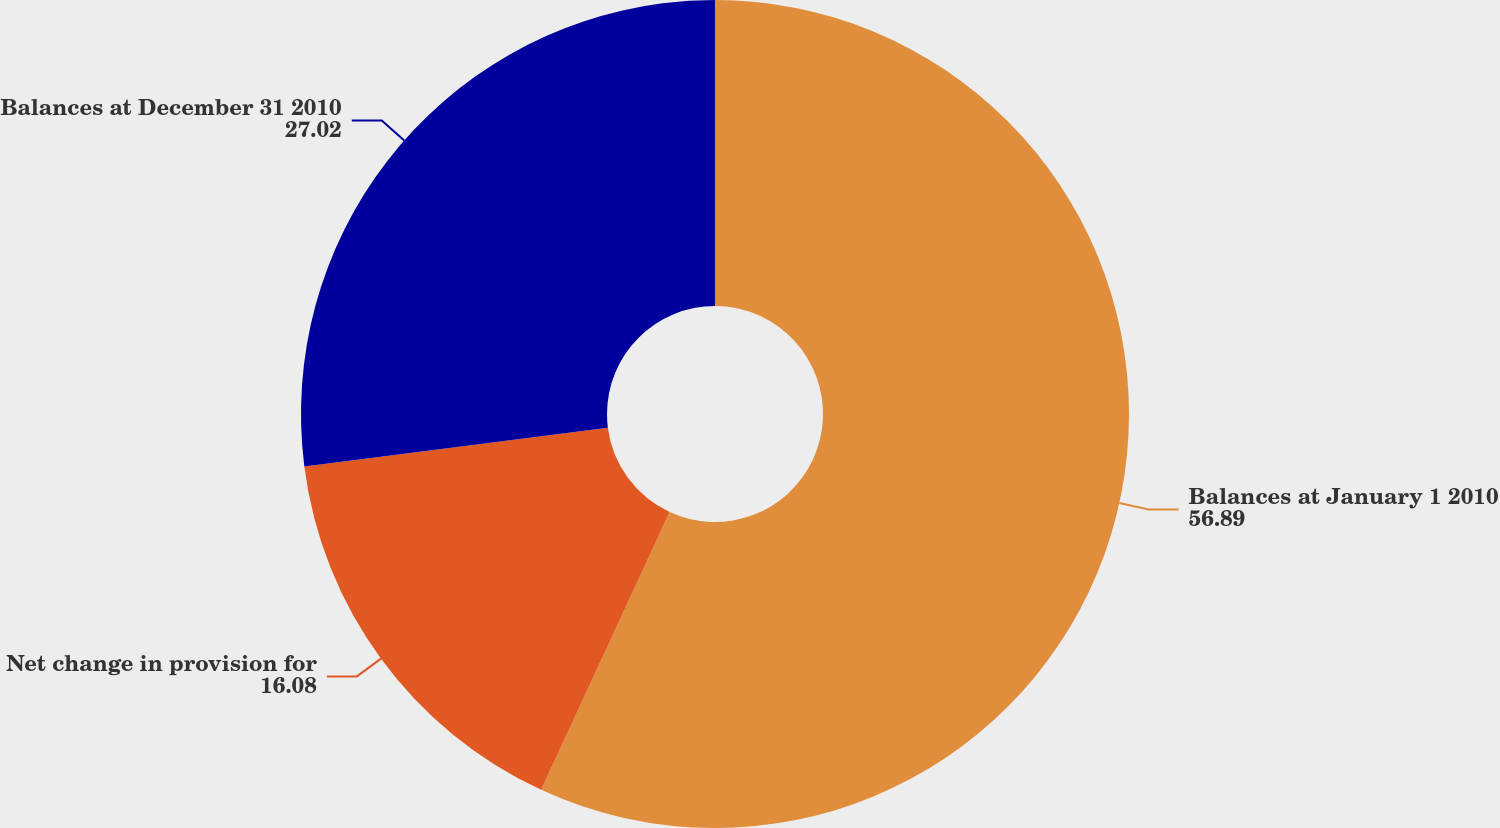<chart> <loc_0><loc_0><loc_500><loc_500><pie_chart><fcel>Balances at January 1 2010<fcel>Net change in provision for<fcel>Balances at December 31 2010<nl><fcel>56.89%<fcel>16.08%<fcel>27.02%<nl></chart> 